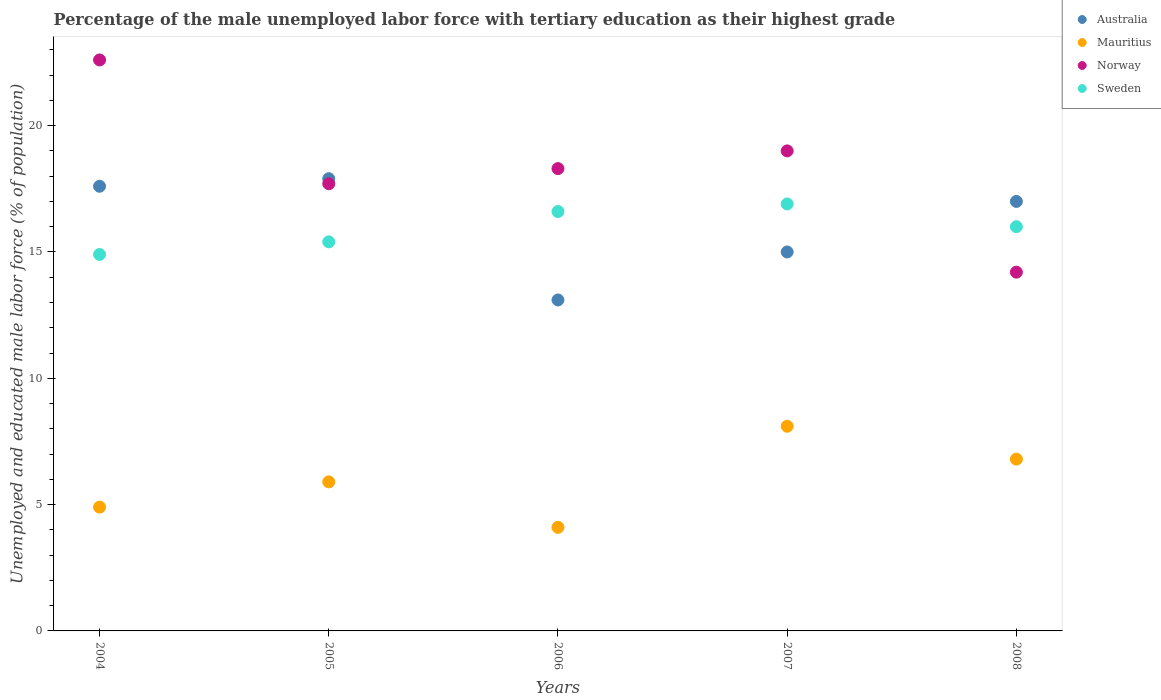How many different coloured dotlines are there?
Give a very brief answer. 4. What is the percentage of the unemployed male labor force with tertiary education in Mauritius in 2007?
Your answer should be very brief. 8.1. Across all years, what is the maximum percentage of the unemployed male labor force with tertiary education in Mauritius?
Your answer should be compact. 8.1. Across all years, what is the minimum percentage of the unemployed male labor force with tertiary education in Mauritius?
Your response must be concise. 4.1. What is the total percentage of the unemployed male labor force with tertiary education in Sweden in the graph?
Provide a short and direct response. 79.8. What is the difference between the percentage of the unemployed male labor force with tertiary education in Australia in 2005 and that in 2007?
Ensure brevity in your answer.  2.9. What is the difference between the percentage of the unemployed male labor force with tertiary education in Norway in 2006 and the percentage of the unemployed male labor force with tertiary education in Australia in 2008?
Offer a very short reply. 1.3. What is the average percentage of the unemployed male labor force with tertiary education in Norway per year?
Offer a terse response. 18.36. In the year 2005, what is the difference between the percentage of the unemployed male labor force with tertiary education in Norway and percentage of the unemployed male labor force with tertiary education in Mauritius?
Your answer should be very brief. 11.8. What is the ratio of the percentage of the unemployed male labor force with tertiary education in Mauritius in 2004 to that in 2006?
Make the answer very short. 1.2. What is the difference between the highest and the second highest percentage of the unemployed male labor force with tertiary education in Australia?
Keep it short and to the point. 0.3. What is the difference between the highest and the lowest percentage of the unemployed male labor force with tertiary education in Norway?
Your response must be concise. 8.4. In how many years, is the percentage of the unemployed male labor force with tertiary education in Australia greater than the average percentage of the unemployed male labor force with tertiary education in Australia taken over all years?
Provide a succinct answer. 3. Is it the case that in every year, the sum of the percentage of the unemployed male labor force with tertiary education in Norway and percentage of the unemployed male labor force with tertiary education in Australia  is greater than the sum of percentage of the unemployed male labor force with tertiary education in Sweden and percentage of the unemployed male labor force with tertiary education in Mauritius?
Your answer should be very brief. Yes. Does the percentage of the unemployed male labor force with tertiary education in Australia monotonically increase over the years?
Give a very brief answer. No. Is the percentage of the unemployed male labor force with tertiary education in Mauritius strictly greater than the percentage of the unemployed male labor force with tertiary education in Australia over the years?
Make the answer very short. No. Is the percentage of the unemployed male labor force with tertiary education in Norway strictly less than the percentage of the unemployed male labor force with tertiary education in Australia over the years?
Your response must be concise. No. How many years are there in the graph?
Make the answer very short. 5. What is the difference between two consecutive major ticks on the Y-axis?
Your answer should be very brief. 5. Are the values on the major ticks of Y-axis written in scientific E-notation?
Make the answer very short. No. Does the graph contain any zero values?
Make the answer very short. No. Does the graph contain grids?
Offer a very short reply. No. What is the title of the graph?
Offer a terse response. Percentage of the male unemployed labor force with tertiary education as their highest grade. Does "Bahamas" appear as one of the legend labels in the graph?
Your answer should be compact. No. What is the label or title of the X-axis?
Make the answer very short. Years. What is the label or title of the Y-axis?
Make the answer very short. Unemployed and educated male labor force (% of population). What is the Unemployed and educated male labor force (% of population) of Australia in 2004?
Keep it short and to the point. 17.6. What is the Unemployed and educated male labor force (% of population) of Mauritius in 2004?
Your response must be concise. 4.9. What is the Unemployed and educated male labor force (% of population) in Norway in 2004?
Your answer should be compact. 22.6. What is the Unemployed and educated male labor force (% of population) of Sweden in 2004?
Provide a short and direct response. 14.9. What is the Unemployed and educated male labor force (% of population) of Australia in 2005?
Ensure brevity in your answer.  17.9. What is the Unemployed and educated male labor force (% of population) in Mauritius in 2005?
Your answer should be very brief. 5.9. What is the Unemployed and educated male labor force (% of population) in Norway in 2005?
Provide a short and direct response. 17.7. What is the Unemployed and educated male labor force (% of population) of Sweden in 2005?
Make the answer very short. 15.4. What is the Unemployed and educated male labor force (% of population) of Australia in 2006?
Your answer should be compact. 13.1. What is the Unemployed and educated male labor force (% of population) in Mauritius in 2006?
Your answer should be very brief. 4.1. What is the Unemployed and educated male labor force (% of population) of Norway in 2006?
Offer a terse response. 18.3. What is the Unemployed and educated male labor force (% of population) in Sweden in 2006?
Provide a succinct answer. 16.6. What is the Unemployed and educated male labor force (% of population) in Australia in 2007?
Your response must be concise. 15. What is the Unemployed and educated male labor force (% of population) of Mauritius in 2007?
Offer a terse response. 8.1. What is the Unemployed and educated male labor force (% of population) in Norway in 2007?
Make the answer very short. 19. What is the Unemployed and educated male labor force (% of population) in Sweden in 2007?
Your answer should be very brief. 16.9. What is the Unemployed and educated male labor force (% of population) in Australia in 2008?
Your response must be concise. 17. What is the Unemployed and educated male labor force (% of population) in Mauritius in 2008?
Offer a very short reply. 6.8. What is the Unemployed and educated male labor force (% of population) in Norway in 2008?
Ensure brevity in your answer.  14.2. What is the Unemployed and educated male labor force (% of population) of Sweden in 2008?
Ensure brevity in your answer.  16. Across all years, what is the maximum Unemployed and educated male labor force (% of population) in Australia?
Offer a very short reply. 17.9. Across all years, what is the maximum Unemployed and educated male labor force (% of population) of Mauritius?
Give a very brief answer. 8.1. Across all years, what is the maximum Unemployed and educated male labor force (% of population) of Norway?
Your answer should be compact. 22.6. Across all years, what is the maximum Unemployed and educated male labor force (% of population) of Sweden?
Your answer should be compact. 16.9. Across all years, what is the minimum Unemployed and educated male labor force (% of population) in Australia?
Keep it short and to the point. 13.1. Across all years, what is the minimum Unemployed and educated male labor force (% of population) of Mauritius?
Offer a terse response. 4.1. Across all years, what is the minimum Unemployed and educated male labor force (% of population) in Norway?
Keep it short and to the point. 14.2. Across all years, what is the minimum Unemployed and educated male labor force (% of population) in Sweden?
Keep it short and to the point. 14.9. What is the total Unemployed and educated male labor force (% of population) of Australia in the graph?
Make the answer very short. 80.6. What is the total Unemployed and educated male labor force (% of population) of Mauritius in the graph?
Provide a short and direct response. 29.8. What is the total Unemployed and educated male labor force (% of population) of Norway in the graph?
Keep it short and to the point. 91.8. What is the total Unemployed and educated male labor force (% of population) in Sweden in the graph?
Your answer should be compact. 79.8. What is the difference between the Unemployed and educated male labor force (% of population) of Norway in 2004 and that in 2005?
Offer a very short reply. 4.9. What is the difference between the Unemployed and educated male labor force (% of population) in Australia in 2004 and that in 2006?
Provide a succinct answer. 4.5. What is the difference between the Unemployed and educated male labor force (% of population) in Mauritius in 2004 and that in 2006?
Your answer should be very brief. 0.8. What is the difference between the Unemployed and educated male labor force (% of population) of Sweden in 2004 and that in 2006?
Offer a terse response. -1.7. What is the difference between the Unemployed and educated male labor force (% of population) of Australia in 2004 and that in 2007?
Your answer should be very brief. 2.6. What is the difference between the Unemployed and educated male labor force (% of population) in Australia in 2004 and that in 2008?
Offer a very short reply. 0.6. What is the difference between the Unemployed and educated male labor force (% of population) in Mauritius in 2005 and that in 2006?
Offer a very short reply. 1.8. What is the difference between the Unemployed and educated male labor force (% of population) in Sweden in 2005 and that in 2006?
Provide a short and direct response. -1.2. What is the difference between the Unemployed and educated male labor force (% of population) in Mauritius in 2005 and that in 2007?
Provide a succinct answer. -2.2. What is the difference between the Unemployed and educated male labor force (% of population) of Australia in 2005 and that in 2008?
Your response must be concise. 0.9. What is the difference between the Unemployed and educated male labor force (% of population) in Mauritius in 2006 and that in 2007?
Ensure brevity in your answer.  -4. What is the difference between the Unemployed and educated male labor force (% of population) of Norway in 2006 and that in 2008?
Your response must be concise. 4.1. What is the difference between the Unemployed and educated male labor force (% of population) of Sweden in 2006 and that in 2008?
Give a very brief answer. 0.6. What is the difference between the Unemployed and educated male labor force (% of population) of Australia in 2007 and that in 2008?
Offer a very short reply. -2. What is the difference between the Unemployed and educated male labor force (% of population) of Australia in 2004 and the Unemployed and educated male labor force (% of population) of Norway in 2005?
Your response must be concise. -0.1. What is the difference between the Unemployed and educated male labor force (% of population) of Australia in 2004 and the Unemployed and educated male labor force (% of population) of Sweden in 2005?
Your answer should be compact. 2.2. What is the difference between the Unemployed and educated male labor force (% of population) in Norway in 2004 and the Unemployed and educated male labor force (% of population) in Sweden in 2005?
Your answer should be very brief. 7.2. What is the difference between the Unemployed and educated male labor force (% of population) in Australia in 2004 and the Unemployed and educated male labor force (% of population) in Norway in 2006?
Provide a short and direct response. -0.7. What is the difference between the Unemployed and educated male labor force (% of population) of Australia in 2004 and the Unemployed and educated male labor force (% of population) of Sweden in 2006?
Ensure brevity in your answer.  1. What is the difference between the Unemployed and educated male labor force (% of population) in Mauritius in 2004 and the Unemployed and educated male labor force (% of population) in Sweden in 2006?
Your answer should be compact. -11.7. What is the difference between the Unemployed and educated male labor force (% of population) in Australia in 2004 and the Unemployed and educated male labor force (% of population) in Mauritius in 2007?
Give a very brief answer. 9.5. What is the difference between the Unemployed and educated male labor force (% of population) of Australia in 2004 and the Unemployed and educated male labor force (% of population) of Sweden in 2007?
Your answer should be compact. 0.7. What is the difference between the Unemployed and educated male labor force (% of population) of Mauritius in 2004 and the Unemployed and educated male labor force (% of population) of Norway in 2007?
Make the answer very short. -14.1. What is the difference between the Unemployed and educated male labor force (% of population) of Australia in 2004 and the Unemployed and educated male labor force (% of population) of Sweden in 2008?
Make the answer very short. 1.6. What is the difference between the Unemployed and educated male labor force (% of population) in Mauritius in 2004 and the Unemployed and educated male labor force (% of population) in Sweden in 2008?
Ensure brevity in your answer.  -11.1. What is the difference between the Unemployed and educated male labor force (% of population) in Australia in 2005 and the Unemployed and educated male labor force (% of population) in Sweden in 2006?
Give a very brief answer. 1.3. What is the difference between the Unemployed and educated male labor force (% of population) in Mauritius in 2005 and the Unemployed and educated male labor force (% of population) in Norway in 2006?
Give a very brief answer. -12.4. What is the difference between the Unemployed and educated male labor force (% of population) in Mauritius in 2005 and the Unemployed and educated male labor force (% of population) in Sweden in 2006?
Keep it short and to the point. -10.7. What is the difference between the Unemployed and educated male labor force (% of population) of Australia in 2005 and the Unemployed and educated male labor force (% of population) of Mauritius in 2007?
Ensure brevity in your answer.  9.8. What is the difference between the Unemployed and educated male labor force (% of population) in Mauritius in 2005 and the Unemployed and educated male labor force (% of population) in Norway in 2007?
Your answer should be very brief. -13.1. What is the difference between the Unemployed and educated male labor force (% of population) in Norway in 2005 and the Unemployed and educated male labor force (% of population) in Sweden in 2007?
Keep it short and to the point. 0.8. What is the difference between the Unemployed and educated male labor force (% of population) of Australia in 2005 and the Unemployed and educated male labor force (% of population) of Sweden in 2008?
Keep it short and to the point. 1.9. What is the difference between the Unemployed and educated male labor force (% of population) of Mauritius in 2005 and the Unemployed and educated male labor force (% of population) of Norway in 2008?
Offer a very short reply. -8.3. What is the difference between the Unemployed and educated male labor force (% of population) in Norway in 2005 and the Unemployed and educated male labor force (% of population) in Sweden in 2008?
Ensure brevity in your answer.  1.7. What is the difference between the Unemployed and educated male labor force (% of population) in Mauritius in 2006 and the Unemployed and educated male labor force (% of population) in Norway in 2007?
Make the answer very short. -14.9. What is the difference between the Unemployed and educated male labor force (% of population) in Mauritius in 2006 and the Unemployed and educated male labor force (% of population) in Sweden in 2007?
Provide a succinct answer. -12.8. What is the difference between the Unemployed and educated male labor force (% of population) in Norway in 2006 and the Unemployed and educated male labor force (% of population) in Sweden in 2007?
Provide a succinct answer. 1.4. What is the difference between the Unemployed and educated male labor force (% of population) in Australia in 2006 and the Unemployed and educated male labor force (% of population) in Mauritius in 2008?
Make the answer very short. 6.3. What is the difference between the Unemployed and educated male labor force (% of population) of Australia in 2006 and the Unemployed and educated male labor force (% of population) of Norway in 2008?
Keep it short and to the point. -1.1. What is the difference between the Unemployed and educated male labor force (% of population) of Australia in 2007 and the Unemployed and educated male labor force (% of population) of Mauritius in 2008?
Ensure brevity in your answer.  8.2. What is the difference between the Unemployed and educated male labor force (% of population) in Australia in 2007 and the Unemployed and educated male labor force (% of population) in Norway in 2008?
Make the answer very short. 0.8. What is the difference between the Unemployed and educated male labor force (% of population) of Mauritius in 2007 and the Unemployed and educated male labor force (% of population) of Norway in 2008?
Keep it short and to the point. -6.1. What is the average Unemployed and educated male labor force (% of population) in Australia per year?
Offer a very short reply. 16.12. What is the average Unemployed and educated male labor force (% of population) of Mauritius per year?
Offer a terse response. 5.96. What is the average Unemployed and educated male labor force (% of population) in Norway per year?
Give a very brief answer. 18.36. What is the average Unemployed and educated male labor force (% of population) in Sweden per year?
Provide a short and direct response. 15.96. In the year 2004, what is the difference between the Unemployed and educated male labor force (% of population) in Australia and Unemployed and educated male labor force (% of population) in Norway?
Offer a terse response. -5. In the year 2004, what is the difference between the Unemployed and educated male labor force (% of population) in Mauritius and Unemployed and educated male labor force (% of population) in Norway?
Offer a very short reply. -17.7. In the year 2004, what is the difference between the Unemployed and educated male labor force (% of population) in Norway and Unemployed and educated male labor force (% of population) in Sweden?
Ensure brevity in your answer.  7.7. In the year 2005, what is the difference between the Unemployed and educated male labor force (% of population) in Australia and Unemployed and educated male labor force (% of population) in Mauritius?
Ensure brevity in your answer.  12. In the year 2005, what is the difference between the Unemployed and educated male labor force (% of population) of Mauritius and Unemployed and educated male labor force (% of population) of Norway?
Keep it short and to the point. -11.8. In the year 2005, what is the difference between the Unemployed and educated male labor force (% of population) of Norway and Unemployed and educated male labor force (% of population) of Sweden?
Make the answer very short. 2.3. In the year 2006, what is the difference between the Unemployed and educated male labor force (% of population) in Australia and Unemployed and educated male labor force (% of population) in Norway?
Keep it short and to the point. -5.2. In the year 2006, what is the difference between the Unemployed and educated male labor force (% of population) in Mauritius and Unemployed and educated male labor force (% of population) in Norway?
Make the answer very short. -14.2. In the year 2006, what is the difference between the Unemployed and educated male labor force (% of population) in Mauritius and Unemployed and educated male labor force (% of population) in Sweden?
Your answer should be very brief. -12.5. In the year 2006, what is the difference between the Unemployed and educated male labor force (% of population) in Norway and Unemployed and educated male labor force (% of population) in Sweden?
Give a very brief answer. 1.7. In the year 2007, what is the difference between the Unemployed and educated male labor force (% of population) of Australia and Unemployed and educated male labor force (% of population) of Sweden?
Give a very brief answer. -1.9. In the year 2007, what is the difference between the Unemployed and educated male labor force (% of population) in Mauritius and Unemployed and educated male labor force (% of population) in Sweden?
Provide a short and direct response. -8.8. In the year 2008, what is the difference between the Unemployed and educated male labor force (% of population) in Australia and Unemployed and educated male labor force (% of population) in Sweden?
Offer a very short reply. 1. In the year 2008, what is the difference between the Unemployed and educated male labor force (% of population) in Mauritius and Unemployed and educated male labor force (% of population) in Norway?
Your answer should be very brief. -7.4. In the year 2008, what is the difference between the Unemployed and educated male labor force (% of population) in Mauritius and Unemployed and educated male labor force (% of population) in Sweden?
Your answer should be very brief. -9.2. In the year 2008, what is the difference between the Unemployed and educated male labor force (% of population) in Norway and Unemployed and educated male labor force (% of population) in Sweden?
Your answer should be compact. -1.8. What is the ratio of the Unemployed and educated male labor force (% of population) in Australia in 2004 to that in 2005?
Ensure brevity in your answer.  0.98. What is the ratio of the Unemployed and educated male labor force (% of population) of Mauritius in 2004 to that in 2005?
Make the answer very short. 0.83. What is the ratio of the Unemployed and educated male labor force (% of population) in Norway in 2004 to that in 2005?
Your answer should be very brief. 1.28. What is the ratio of the Unemployed and educated male labor force (% of population) of Sweden in 2004 to that in 2005?
Provide a succinct answer. 0.97. What is the ratio of the Unemployed and educated male labor force (% of population) in Australia in 2004 to that in 2006?
Your answer should be compact. 1.34. What is the ratio of the Unemployed and educated male labor force (% of population) of Mauritius in 2004 to that in 2006?
Your answer should be compact. 1.2. What is the ratio of the Unemployed and educated male labor force (% of population) of Norway in 2004 to that in 2006?
Keep it short and to the point. 1.24. What is the ratio of the Unemployed and educated male labor force (% of population) in Sweden in 2004 to that in 2006?
Make the answer very short. 0.9. What is the ratio of the Unemployed and educated male labor force (% of population) of Australia in 2004 to that in 2007?
Ensure brevity in your answer.  1.17. What is the ratio of the Unemployed and educated male labor force (% of population) of Mauritius in 2004 to that in 2007?
Keep it short and to the point. 0.6. What is the ratio of the Unemployed and educated male labor force (% of population) of Norway in 2004 to that in 2007?
Your response must be concise. 1.19. What is the ratio of the Unemployed and educated male labor force (% of population) of Sweden in 2004 to that in 2007?
Your answer should be very brief. 0.88. What is the ratio of the Unemployed and educated male labor force (% of population) of Australia in 2004 to that in 2008?
Your answer should be very brief. 1.04. What is the ratio of the Unemployed and educated male labor force (% of population) in Mauritius in 2004 to that in 2008?
Your answer should be compact. 0.72. What is the ratio of the Unemployed and educated male labor force (% of population) in Norway in 2004 to that in 2008?
Provide a short and direct response. 1.59. What is the ratio of the Unemployed and educated male labor force (% of population) of Sweden in 2004 to that in 2008?
Make the answer very short. 0.93. What is the ratio of the Unemployed and educated male labor force (% of population) of Australia in 2005 to that in 2006?
Provide a succinct answer. 1.37. What is the ratio of the Unemployed and educated male labor force (% of population) in Mauritius in 2005 to that in 2006?
Give a very brief answer. 1.44. What is the ratio of the Unemployed and educated male labor force (% of population) of Norway in 2005 to that in 2006?
Ensure brevity in your answer.  0.97. What is the ratio of the Unemployed and educated male labor force (% of population) of Sweden in 2005 to that in 2006?
Give a very brief answer. 0.93. What is the ratio of the Unemployed and educated male labor force (% of population) of Australia in 2005 to that in 2007?
Provide a succinct answer. 1.19. What is the ratio of the Unemployed and educated male labor force (% of population) of Mauritius in 2005 to that in 2007?
Ensure brevity in your answer.  0.73. What is the ratio of the Unemployed and educated male labor force (% of population) of Norway in 2005 to that in 2007?
Your answer should be very brief. 0.93. What is the ratio of the Unemployed and educated male labor force (% of population) in Sweden in 2005 to that in 2007?
Provide a short and direct response. 0.91. What is the ratio of the Unemployed and educated male labor force (% of population) of Australia in 2005 to that in 2008?
Provide a succinct answer. 1.05. What is the ratio of the Unemployed and educated male labor force (% of population) of Mauritius in 2005 to that in 2008?
Ensure brevity in your answer.  0.87. What is the ratio of the Unemployed and educated male labor force (% of population) of Norway in 2005 to that in 2008?
Offer a very short reply. 1.25. What is the ratio of the Unemployed and educated male labor force (% of population) in Sweden in 2005 to that in 2008?
Keep it short and to the point. 0.96. What is the ratio of the Unemployed and educated male labor force (% of population) in Australia in 2006 to that in 2007?
Provide a short and direct response. 0.87. What is the ratio of the Unemployed and educated male labor force (% of population) of Mauritius in 2006 to that in 2007?
Offer a terse response. 0.51. What is the ratio of the Unemployed and educated male labor force (% of population) in Norway in 2006 to that in 2007?
Ensure brevity in your answer.  0.96. What is the ratio of the Unemployed and educated male labor force (% of population) of Sweden in 2006 to that in 2007?
Make the answer very short. 0.98. What is the ratio of the Unemployed and educated male labor force (% of population) of Australia in 2006 to that in 2008?
Keep it short and to the point. 0.77. What is the ratio of the Unemployed and educated male labor force (% of population) of Mauritius in 2006 to that in 2008?
Your answer should be compact. 0.6. What is the ratio of the Unemployed and educated male labor force (% of population) in Norway in 2006 to that in 2008?
Provide a short and direct response. 1.29. What is the ratio of the Unemployed and educated male labor force (% of population) of Sweden in 2006 to that in 2008?
Offer a very short reply. 1.04. What is the ratio of the Unemployed and educated male labor force (% of population) of Australia in 2007 to that in 2008?
Your answer should be very brief. 0.88. What is the ratio of the Unemployed and educated male labor force (% of population) of Mauritius in 2007 to that in 2008?
Your response must be concise. 1.19. What is the ratio of the Unemployed and educated male labor force (% of population) in Norway in 2007 to that in 2008?
Your answer should be very brief. 1.34. What is the ratio of the Unemployed and educated male labor force (% of population) of Sweden in 2007 to that in 2008?
Make the answer very short. 1.06. What is the difference between the highest and the second highest Unemployed and educated male labor force (% of population) in Australia?
Keep it short and to the point. 0.3. What is the difference between the highest and the second highest Unemployed and educated male labor force (% of population) in Mauritius?
Your response must be concise. 1.3. What is the difference between the highest and the second highest Unemployed and educated male labor force (% of population) in Norway?
Provide a succinct answer. 3.6. What is the difference between the highest and the lowest Unemployed and educated male labor force (% of population) in Mauritius?
Keep it short and to the point. 4. What is the difference between the highest and the lowest Unemployed and educated male labor force (% of population) in Norway?
Your answer should be very brief. 8.4. 